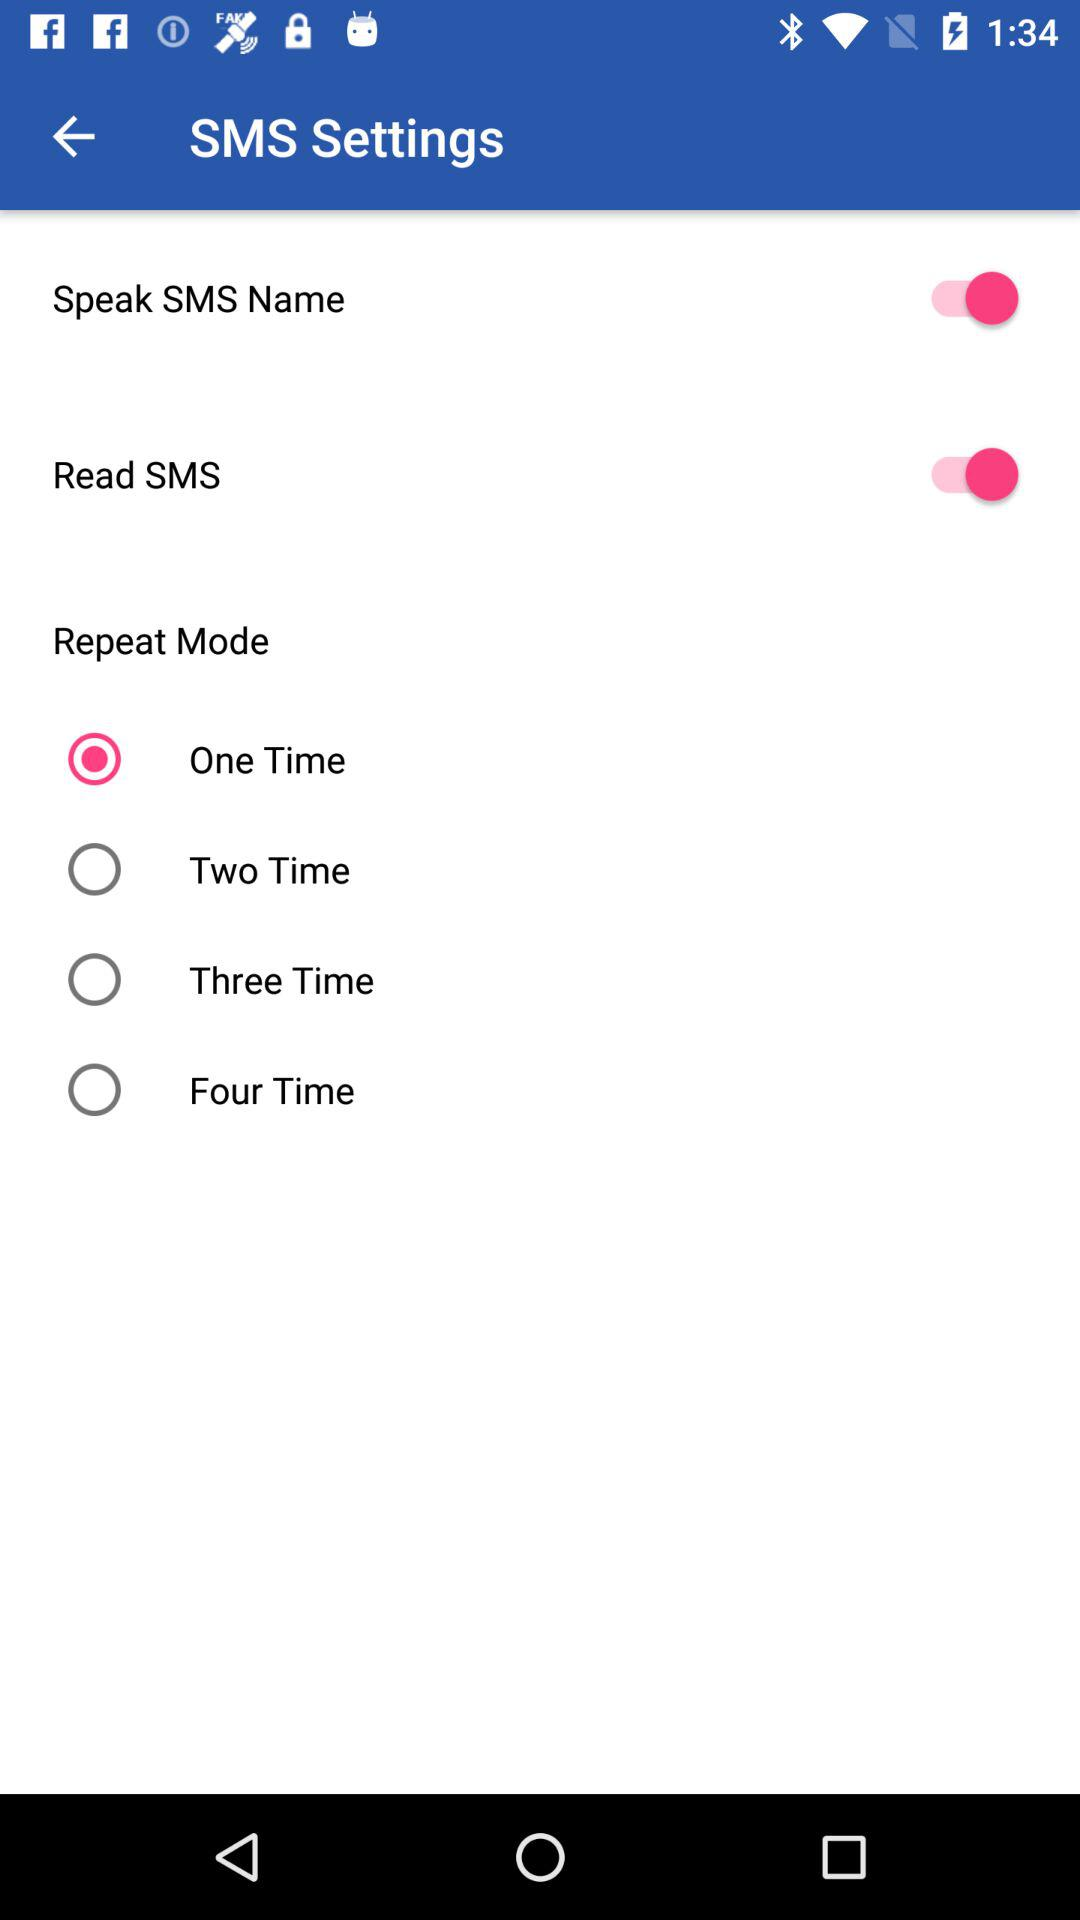What is the selected option in "Repeat Mode"? The selected option is "One Time". 